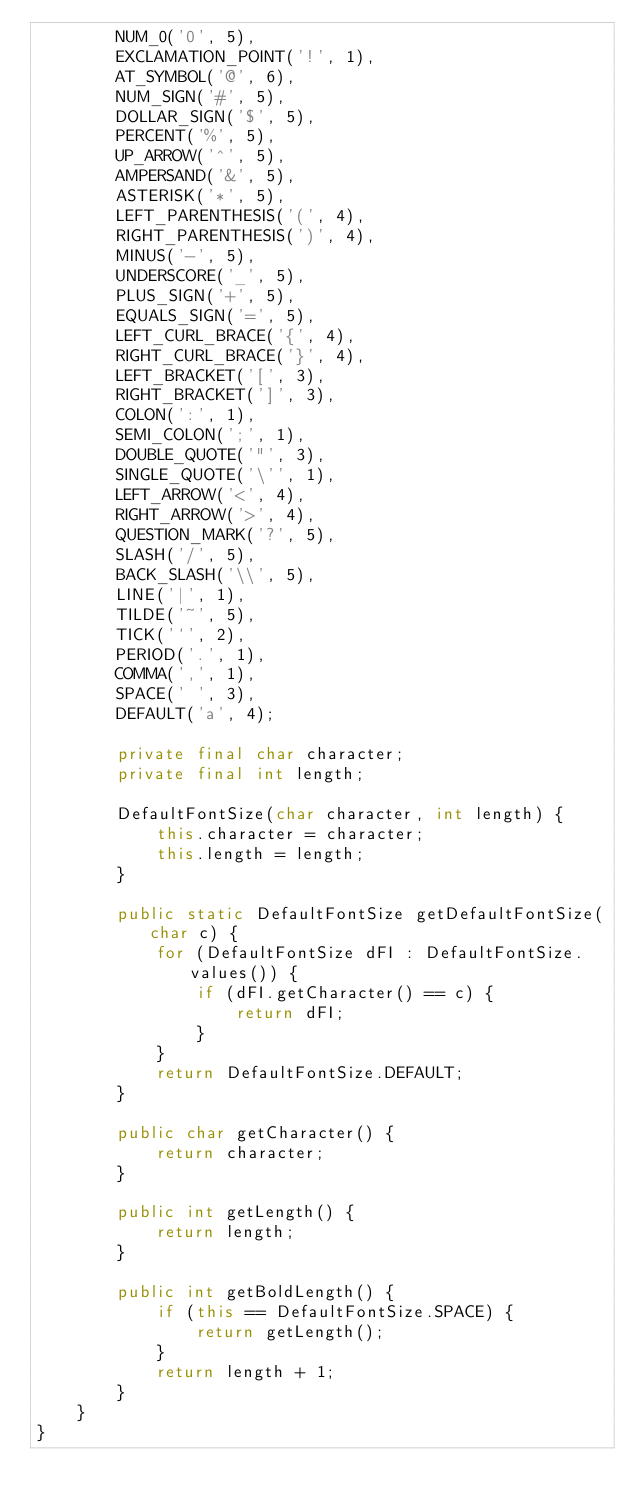<code> <loc_0><loc_0><loc_500><loc_500><_Java_>        NUM_0('0', 5),
        EXCLAMATION_POINT('!', 1),
        AT_SYMBOL('@', 6),
        NUM_SIGN('#', 5),
        DOLLAR_SIGN('$', 5),
        PERCENT('%', 5),
        UP_ARROW('^', 5),
        AMPERSAND('&', 5),
        ASTERISK('*', 5),
        LEFT_PARENTHESIS('(', 4),
        RIGHT_PARENTHESIS(')', 4),
        MINUS('-', 5),
        UNDERSCORE('_', 5),
        PLUS_SIGN('+', 5),
        EQUALS_SIGN('=', 5),
        LEFT_CURL_BRACE('{', 4),
        RIGHT_CURL_BRACE('}', 4),
        LEFT_BRACKET('[', 3),
        RIGHT_BRACKET(']', 3),
        COLON(':', 1),
        SEMI_COLON(';', 1),
        DOUBLE_QUOTE('"', 3),
        SINGLE_QUOTE('\'', 1),
        LEFT_ARROW('<', 4),
        RIGHT_ARROW('>', 4),
        QUESTION_MARK('?', 5),
        SLASH('/', 5),
        BACK_SLASH('\\', 5),
        LINE('|', 1),
        TILDE('~', 5),
        TICK('`', 2),
        PERIOD('.', 1),
        COMMA(',', 1),
        SPACE(' ', 3),
        DEFAULT('a', 4);

        private final char character;
        private final int length;

        DefaultFontSize(char character, int length) {
            this.character = character;
            this.length = length;
        }

        public static DefaultFontSize getDefaultFontSize(char c) {
            for (DefaultFontSize dFI : DefaultFontSize.values()) {
                if (dFI.getCharacter() == c) {
                    return dFI;
                }
            }
            return DefaultFontSize.DEFAULT;
        }

        public char getCharacter() {
            return character;
        }

        public int getLength() {
            return length;
        }

        public int getBoldLength() {
            if (this == DefaultFontSize.SPACE) {
                return getLength();
            }
            return length + 1;
        }
    }
}</code> 